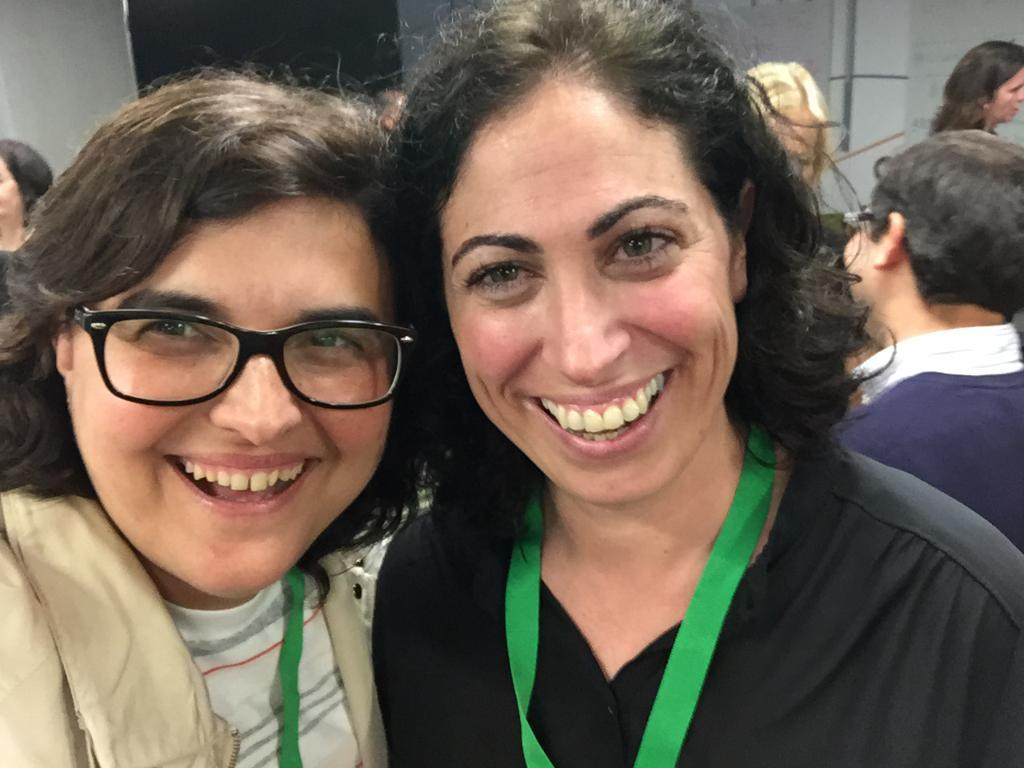How many women are in the image? There are two women in the image. What are the women wearing? Both women are wearing tags. What expression do the women have? The women are smiling. Can you describe the appearance of the woman on the left side? The woman on the left side is wearing glasses. What can be seen in the background of the image? There are many people in the background of the image. What type of spark can be seen coming from the stranger's hand in the image? There is no stranger present in the image, and therefore no spark can be seen coming from their hand. 